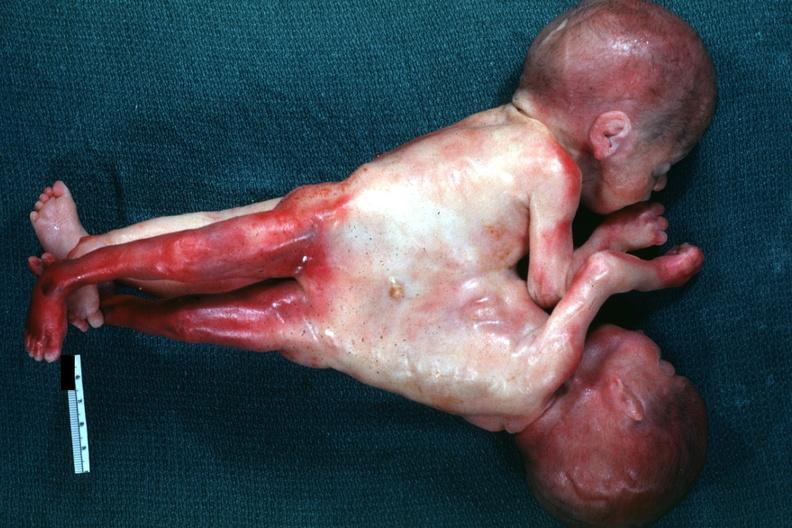what is very good example joined?
Answer the question using a single word or phrase. Abdomen and lower chest anterior 